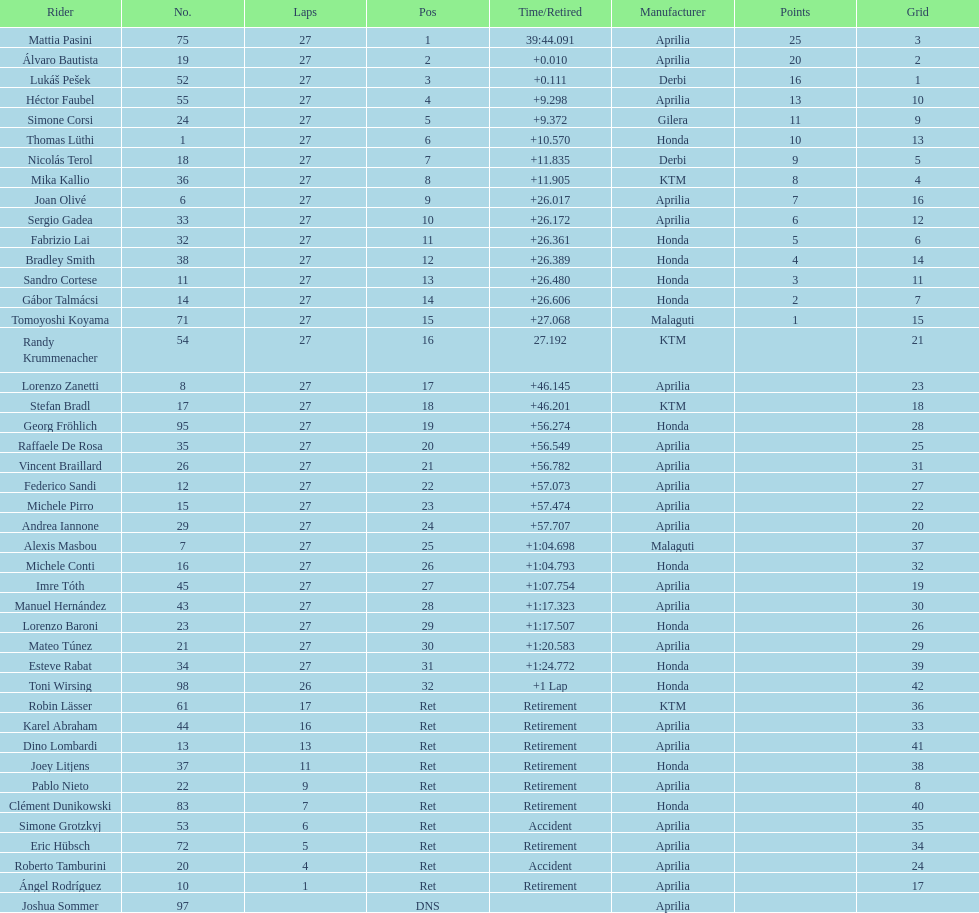Out of all the people who have points, who has the least? Tomoyoshi Koyama. 